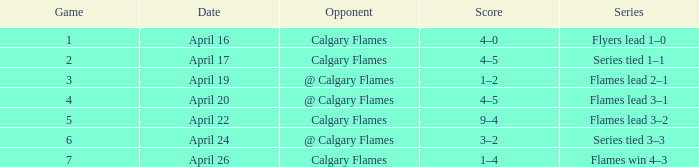Which Series has an Opponent of calgary flames, and a Score of 9–4? Flames lead 3–2. 